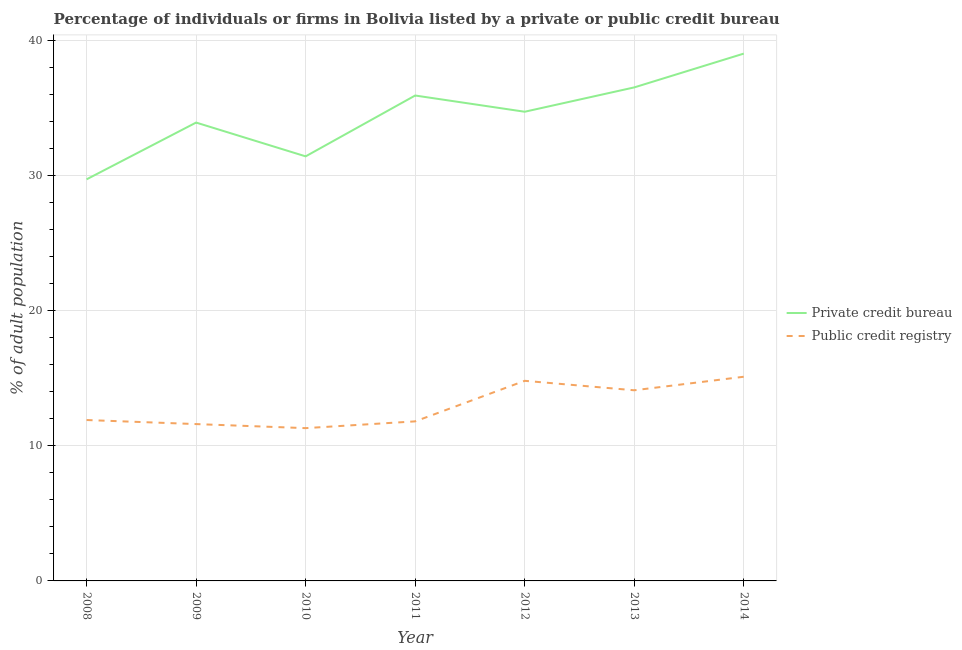Does the line corresponding to percentage of firms listed by private credit bureau intersect with the line corresponding to percentage of firms listed by public credit bureau?
Your answer should be very brief. No. What is the percentage of firms listed by public credit bureau in 2013?
Your answer should be very brief. 14.1. In which year was the percentage of firms listed by private credit bureau minimum?
Offer a terse response. 2008. What is the total percentage of firms listed by private credit bureau in the graph?
Provide a short and direct response. 241.1. What is the difference between the percentage of firms listed by public credit bureau in 2008 and that in 2010?
Offer a terse response. 0.6. What is the difference between the percentage of firms listed by private credit bureau in 2008 and the percentage of firms listed by public credit bureau in 2014?
Your answer should be very brief. 14.6. What is the average percentage of firms listed by private credit bureau per year?
Your answer should be very brief. 34.44. In the year 2009, what is the difference between the percentage of firms listed by public credit bureau and percentage of firms listed by private credit bureau?
Your response must be concise. -22.3. In how many years, is the percentage of firms listed by private credit bureau greater than 2 %?
Offer a terse response. 7. What is the ratio of the percentage of firms listed by public credit bureau in 2011 to that in 2014?
Provide a succinct answer. 0.78. Is the difference between the percentage of firms listed by private credit bureau in 2010 and 2013 greater than the difference between the percentage of firms listed by public credit bureau in 2010 and 2013?
Provide a short and direct response. No. In how many years, is the percentage of firms listed by private credit bureau greater than the average percentage of firms listed by private credit bureau taken over all years?
Offer a terse response. 4. Is the sum of the percentage of firms listed by public credit bureau in 2008 and 2012 greater than the maximum percentage of firms listed by private credit bureau across all years?
Offer a very short reply. No. Are the values on the major ticks of Y-axis written in scientific E-notation?
Your answer should be very brief. No. Does the graph contain any zero values?
Your answer should be very brief. No. Where does the legend appear in the graph?
Make the answer very short. Center right. How many legend labels are there?
Provide a short and direct response. 2. What is the title of the graph?
Your answer should be compact. Percentage of individuals or firms in Bolivia listed by a private or public credit bureau. Does "Total Population" appear as one of the legend labels in the graph?
Provide a short and direct response. No. What is the label or title of the Y-axis?
Keep it short and to the point. % of adult population. What is the % of adult population of Private credit bureau in 2008?
Give a very brief answer. 29.7. What is the % of adult population of Private credit bureau in 2009?
Ensure brevity in your answer.  33.9. What is the % of adult population of Private credit bureau in 2010?
Ensure brevity in your answer.  31.4. What is the % of adult population of Private credit bureau in 2011?
Provide a succinct answer. 35.9. What is the % of adult population in Public credit registry in 2011?
Your answer should be very brief. 11.8. What is the % of adult population of Private credit bureau in 2012?
Keep it short and to the point. 34.7. What is the % of adult population in Public credit registry in 2012?
Give a very brief answer. 14.8. What is the % of adult population of Private credit bureau in 2013?
Your response must be concise. 36.5. Across all years, what is the maximum % of adult population of Private credit bureau?
Make the answer very short. 39. Across all years, what is the minimum % of adult population in Private credit bureau?
Your response must be concise. 29.7. Across all years, what is the minimum % of adult population in Public credit registry?
Offer a very short reply. 11.3. What is the total % of adult population in Private credit bureau in the graph?
Provide a short and direct response. 241.1. What is the total % of adult population in Public credit registry in the graph?
Your answer should be compact. 90.6. What is the difference between the % of adult population in Public credit registry in 2008 and that in 2010?
Keep it short and to the point. 0.6. What is the difference between the % of adult population of Public credit registry in 2008 and that in 2011?
Offer a very short reply. 0.1. What is the difference between the % of adult population in Private credit bureau in 2008 and that in 2012?
Provide a short and direct response. -5. What is the difference between the % of adult population of Public credit registry in 2008 and that in 2012?
Provide a short and direct response. -2.9. What is the difference between the % of adult population in Public credit registry in 2008 and that in 2013?
Provide a succinct answer. -2.2. What is the difference between the % of adult population in Private credit bureau in 2009 and that in 2010?
Provide a succinct answer. 2.5. What is the difference between the % of adult population in Public credit registry in 2009 and that in 2010?
Offer a very short reply. 0.3. What is the difference between the % of adult population of Private credit bureau in 2009 and that in 2011?
Provide a succinct answer. -2. What is the difference between the % of adult population of Public credit registry in 2009 and that in 2011?
Give a very brief answer. -0.2. What is the difference between the % of adult population of Public credit registry in 2009 and that in 2013?
Make the answer very short. -2.5. What is the difference between the % of adult population in Private credit bureau in 2009 and that in 2014?
Keep it short and to the point. -5.1. What is the difference between the % of adult population in Public credit registry in 2010 and that in 2011?
Give a very brief answer. -0.5. What is the difference between the % of adult population in Private credit bureau in 2010 and that in 2014?
Keep it short and to the point. -7.6. What is the difference between the % of adult population in Public credit registry in 2010 and that in 2014?
Make the answer very short. -3.8. What is the difference between the % of adult population in Public credit registry in 2011 and that in 2012?
Give a very brief answer. -3. What is the difference between the % of adult population of Private credit bureau in 2011 and that in 2014?
Provide a succinct answer. -3.1. What is the difference between the % of adult population in Public credit registry in 2011 and that in 2014?
Your answer should be compact. -3.3. What is the difference between the % of adult population of Private credit bureau in 2012 and that in 2014?
Your answer should be very brief. -4.3. What is the difference between the % of adult population in Private credit bureau in 2013 and that in 2014?
Keep it short and to the point. -2.5. What is the difference between the % of adult population in Private credit bureau in 2008 and the % of adult population in Public credit registry in 2009?
Offer a terse response. 18.1. What is the difference between the % of adult population of Private credit bureau in 2008 and the % of adult population of Public credit registry in 2010?
Offer a terse response. 18.4. What is the difference between the % of adult population of Private credit bureau in 2009 and the % of adult population of Public credit registry in 2010?
Give a very brief answer. 22.6. What is the difference between the % of adult population in Private credit bureau in 2009 and the % of adult population in Public credit registry in 2011?
Your answer should be compact. 22.1. What is the difference between the % of adult population in Private credit bureau in 2009 and the % of adult population in Public credit registry in 2013?
Offer a terse response. 19.8. What is the difference between the % of adult population in Private credit bureau in 2009 and the % of adult population in Public credit registry in 2014?
Keep it short and to the point. 18.8. What is the difference between the % of adult population of Private credit bureau in 2010 and the % of adult population of Public credit registry in 2011?
Ensure brevity in your answer.  19.6. What is the difference between the % of adult population of Private credit bureau in 2010 and the % of adult population of Public credit registry in 2012?
Keep it short and to the point. 16.6. What is the difference between the % of adult population of Private credit bureau in 2010 and the % of adult population of Public credit registry in 2013?
Your answer should be compact. 17.3. What is the difference between the % of adult population in Private credit bureau in 2010 and the % of adult population in Public credit registry in 2014?
Keep it short and to the point. 16.3. What is the difference between the % of adult population of Private credit bureau in 2011 and the % of adult population of Public credit registry in 2012?
Keep it short and to the point. 21.1. What is the difference between the % of adult population of Private credit bureau in 2011 and the % of adult population of Public credit registry in 2013?
Offer a terse response. 21.8. What is the difference between the % of adult population in Private credit bureau in 2011 and the % of adult population in Public credit registry in 2014?
Keep it short and to the point. 20.8. What is the difference between the % of adult population in Private credit bureau in 2012 and the % of adult population in Public credit registry in 2013?
Ensure brevity in your answer.  20.6. What is the difference between the % of adult population in Private credit bureau in 2012 and the % of adult population in Public credit registry in 2014?
Make the answer very short. 19.6. What is the difference between the % of adult population in Private credit bureau in 2013 and the % of adult population in Public credit registry in 2014?
Give a very brief answer. 21.4. What is the average % of adult population of Private credit bureau per year?
Ensure brevity in your answer.  34.44. What is the average % of adult population in Public credit registry per year?
Your answer should be very brief. 12.94. In the year 2009, what is the difference between the % of adult population in Private credit bureau and % of adult population in Public credit registry?
Give a very brief answer. 22.3. In the year 2010, what is the difference between the % of adult population of Private credit bureau and % of adult population of Public credit registry?
Your answer should be very brief. 20.1. In the year 2011, what is the difference between the % of adult population of Private credit bureau and % of adult population of Public credit registry?
Make the answer very short. 24.1. In the year 2013, what is the difference between the % of adult population of Private credit bureau and % of adult population of Public credit registry?
Your response must be concise. 22.4. In the year 2014, what is the difference between the % of adult population of Private credit bureau and % of adult population of Public credit registry?
Offer a very short reply. 23.9. What is the ratio of the % of adult population in Private credit bureau in 2008 to that in 2009?
Offer a very short reply. 0.88. What is the ratio of the % of adult population of Public credit registry in 2008 to that in 2009?
Your response must be concise. 1.03. What is the ratio of the % of adult population in Private credit bureau in 2008 to that in 2010?
Make the answer very short. 0.95. What is the ratio of the % of adult population of Public credit registry in 2008 to that in 2010?
Ensure brevity in your answer.  1.05. What is the ratio of the % of adult population in Private credit bureau in 2008 to that in 2011?
Your answer should be very brief. 0.83. What is the ratio of the % of adult population of Public credit registry in 2008 to that in 2011?
Your answer should be very brief. 1.01. What is the ratio of the % of adult population in Private credit bureau in 2008 to that in 2012?
Keep it short and to the point. 0.86. What is the ratio of the % of adult population in Public credit registry in 2008 to that in 2012?
Offer a very short reply. 0.8. What is the ratio of the % of adult population of Private credit bureau in 2008 to that in 2013?
Keep it short and to the point. 0.81. What is the ratio of the % of adult population in Public credit registry in 2008 to that in 2013?
Provide a succinct answer. 0.84. What is the ratio of the % of adult population of Private credit bureau in 2008 to that in 2014?
Keep it short and to the point. 0.76. What is the ratio of the % of adult population of Public credit registry in 2008 to that in 2014?
Give a very brief answer. 0.79. What is the ratio of the % of adult population of Private credit bureau in 2009 to that in 2010?
Your answer should be very brief. 1.08. What is the ratio of the % of adult population in Public credit registry in 2009 to that in 2010?
Provide a short and direct response. 1.03. What is the ratio of the % of adult population of Private credit bureau in 2009 to that in 2011?
Give a very brief answer. 0.94. What is the ratio of the % of adult population in Public credit registry in 2009 to that in 2011?
Offer a terse response. 0.98. What is the ratio of the % of adult population in Private credit bureau in 2009 to that in 2012?
Offer a very short reply. 0.98. What is the ratio of the % of adult population of Public credit registry in 2009 to that in 2012?
Your answer should be compact. 0.78. What is the ratio of the % of adult population in Private credit bureau in 2009 to that in 2013?
Provide a short and direct response. 0.93. What is the ratio of the % of adult population of Public credit registry in 2009 to that in 2013?
Offer a very short reply. 0.82. What is the ratio of the % of adult population in Private credit bureau in 2009 to that in 2014?
Offer a very short reply. 0.87. What is the ratio of the % of adult population in Public credit registry in 2009 to that in 2014?
Offer a very short reply. 0.77. What is the ratio of the % of adult population of Private credit bureau in 2010 to that in 2011?
Give a very brief answer. 0.87. What is the ratio of the % of adult population of Public credit registry in 2010 to that in 2011?
Make the answer very short. 0.96. What is the ratio of the % of adult population of Private credit bureau in 2010 to that in 2012?
Make the answer very short. 0.9. What is the ratio of the % of adult population in Public credit registry in 2010 to that in 2012?
Ensure brevity in your answer.  0.76. What is the ratio of the % of adult population in Private credit bureau in 2010 to that in 2013?
Offer a terse response. 0.86. What is the ratio of the % of adult population of Public credit registry in 2010 to that in 2013?
Provide a short and direct response. 0.8. What is the ratio of the % of adult population in Private credit bureau in 2010 to that in 2014?
Provide a succinct answer. 0.81. What is the ratio of the % of adult population of Public credit registry in 2010 to that in 2014?
Your answer should be very brief. 0.75. What is the ratio of the % of adult population in Private credit bureau in 2011 to that in 2012?
Your answer should be compact. 1.03. What is the ratio of the % of adult population in Public credit registry in 2011 to that in 2012?
Your answer should be compact. 0.8. What is the ratio of the % of adult population in Private credit bureau in 2011 to that in 2013?
Provide a short and direct response. 0.98. What is the ratio of the % of adult population in Public credit registry in 2011 to that in 2013?
Ensure brevity in your answer.  0.84. What is the ratio of the % of adult population in Private credit bureau in 2011 to that in 2014?
Keep it short and to the point. 0.92. What is the ratio of the % of adult population in Public credit registry in 2011 to that in 2014?
Your answer should be very brief. 0.78. What is the ratio of the % of adult population of Private credit bureau in 2012 to that in 2013?
Provide a succinct answer. 0.95. What is the ratio of the % of adult population in Public credit registry in 2012 to that in 2013?
Provide a succinct answer. 1.05. What is the ratio of the % of adult population in Private credit bureau in 2012 to that in 2014?
Your answer should be compact. 0.89. What is the ratio of the % of adult population in Public credit registry in 2012 to that in 2014?
Provide a succinct answer. 0.98. What is the ratio of the % of adult population of Private credit bureau in 2013 to that in 2014?
Offer a terse response. 0.94. What is the ratio of the % of adult population in Public credit registry in 2013 to that in 2014?
Ensure brevity in your answer.  0.93. What is the difference between the highest and the second highest % of adult population of Private credit bureau?
Offer a terse response. 2.5. What is the difference between the highest and the lowest % of adult population in Private credit bureau?
Your answer should be compact. 9.3. 